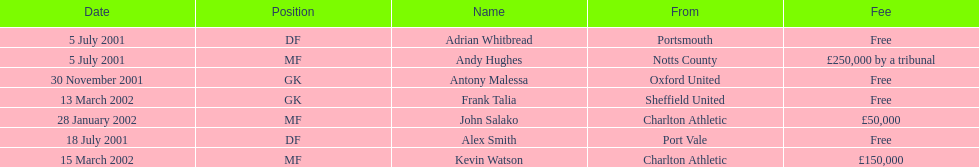Did andy hughes or john salako command the largest fee? Andy Hughes. 